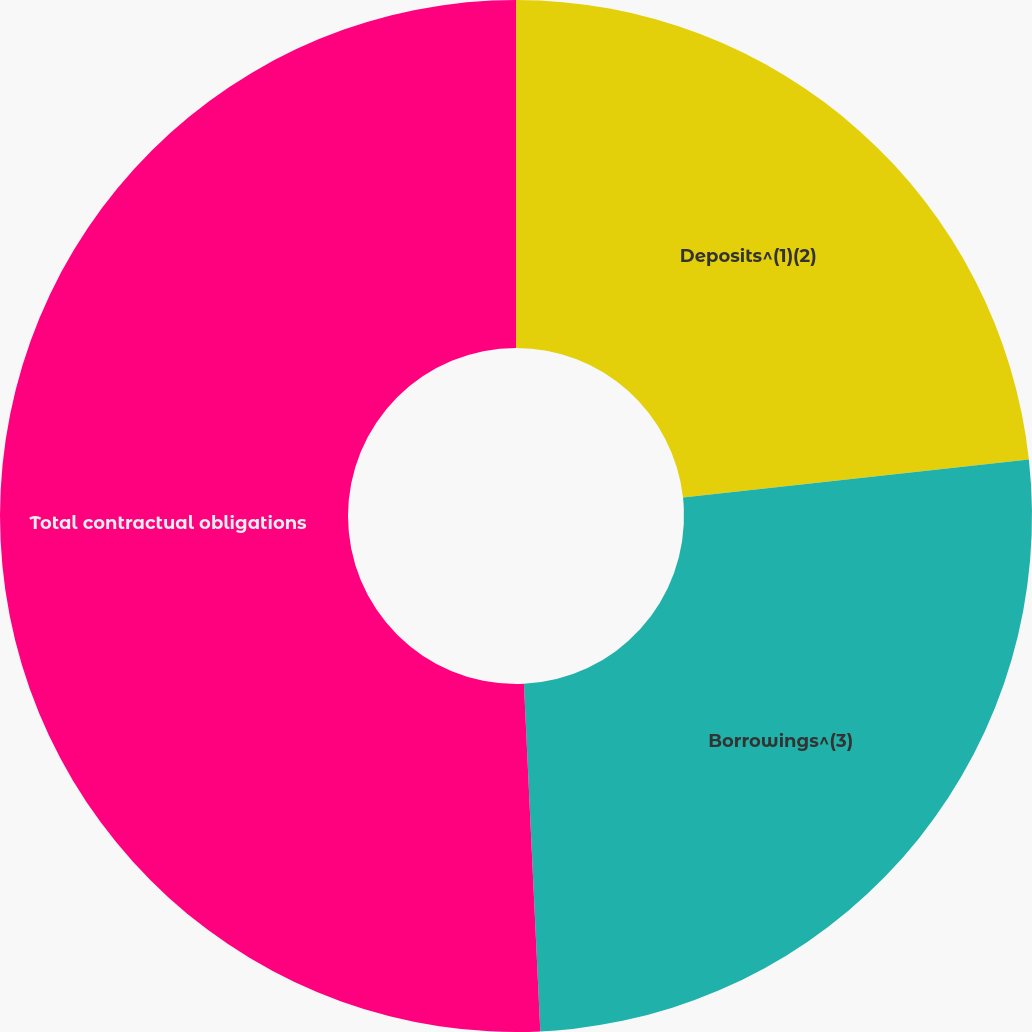Convert chart. <chart><loc_0><loc_0><loc_500><loc_500><pie_chart><fcel>Deposits^(1)(2)<fcel>Borrowings^(3)<fcel>Total contractual obligations<nl><fcel>23.25%<fcel>26.0%<fcel>50.75%<nl></chart> 